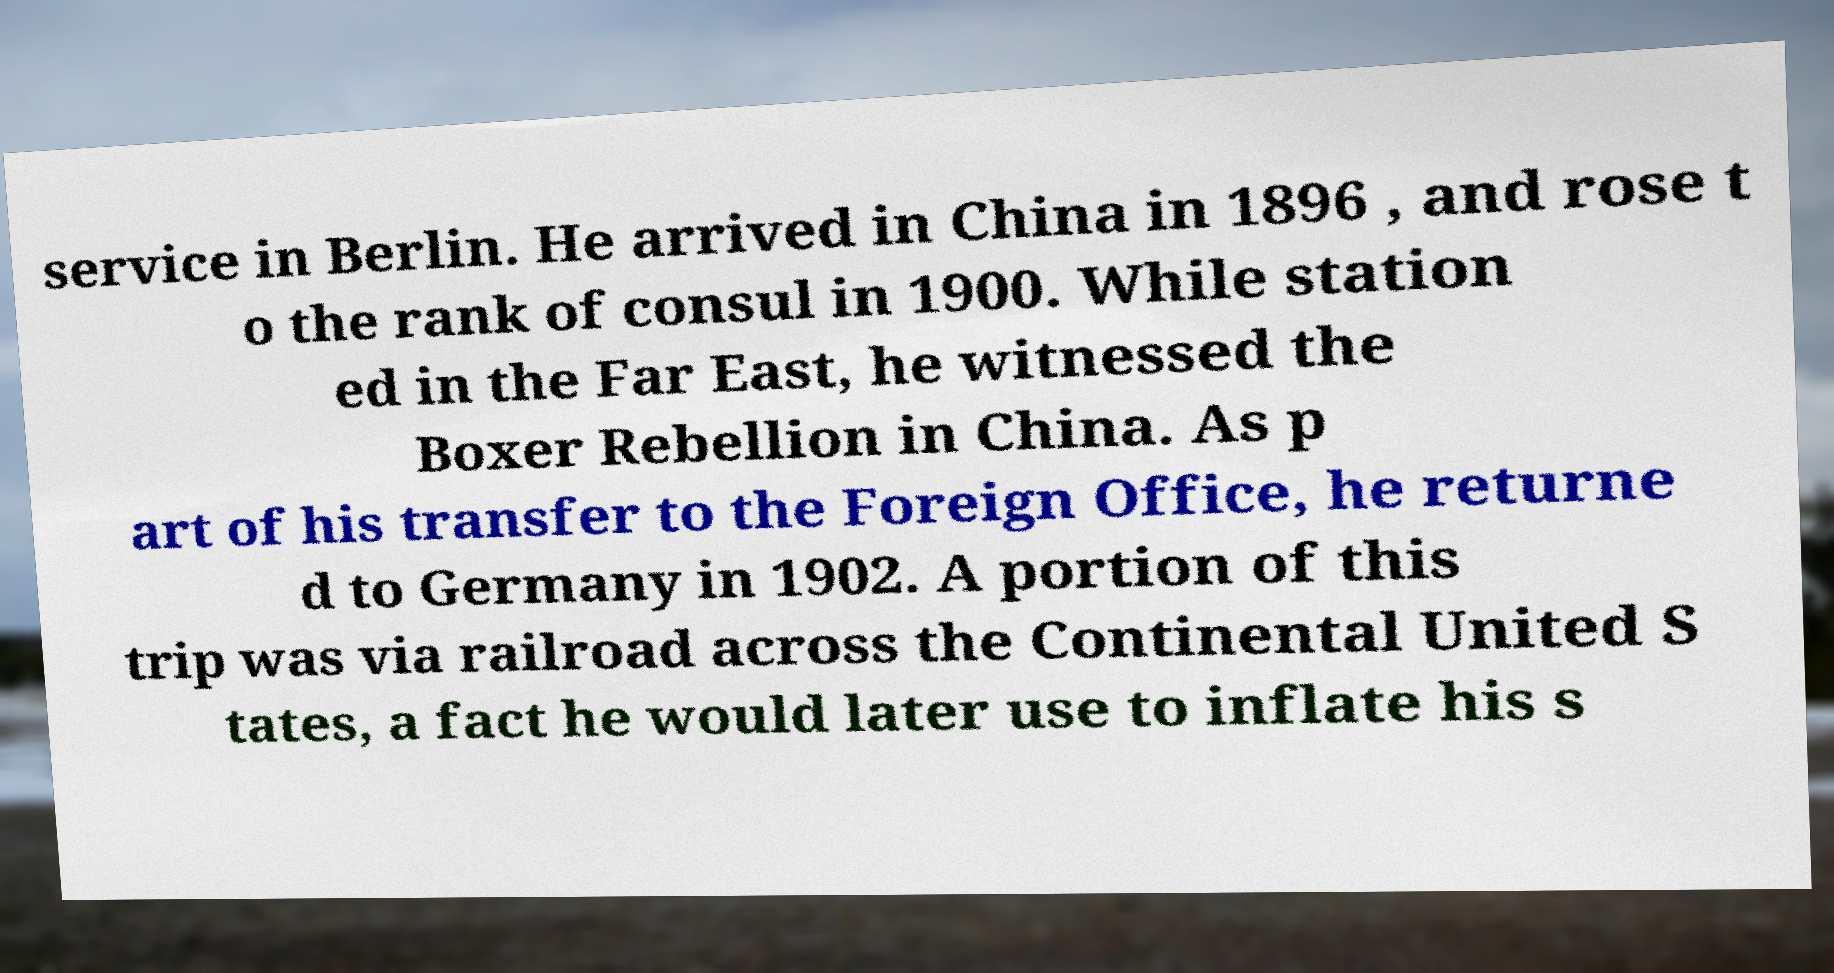Could you extract and type out the text from this image? service in Berlin. He arrived in China in 1896 , and rose t o the rank of consul in 1900. While station ed in the Far East, he witnessed the Boxer Rebellion in China. As p art of his transfer to the Foreign Office, he returne d to Germany in 1902. A portion of this trip was via railroad across the Continental United S tates, a fact he would later use to inflate his s 